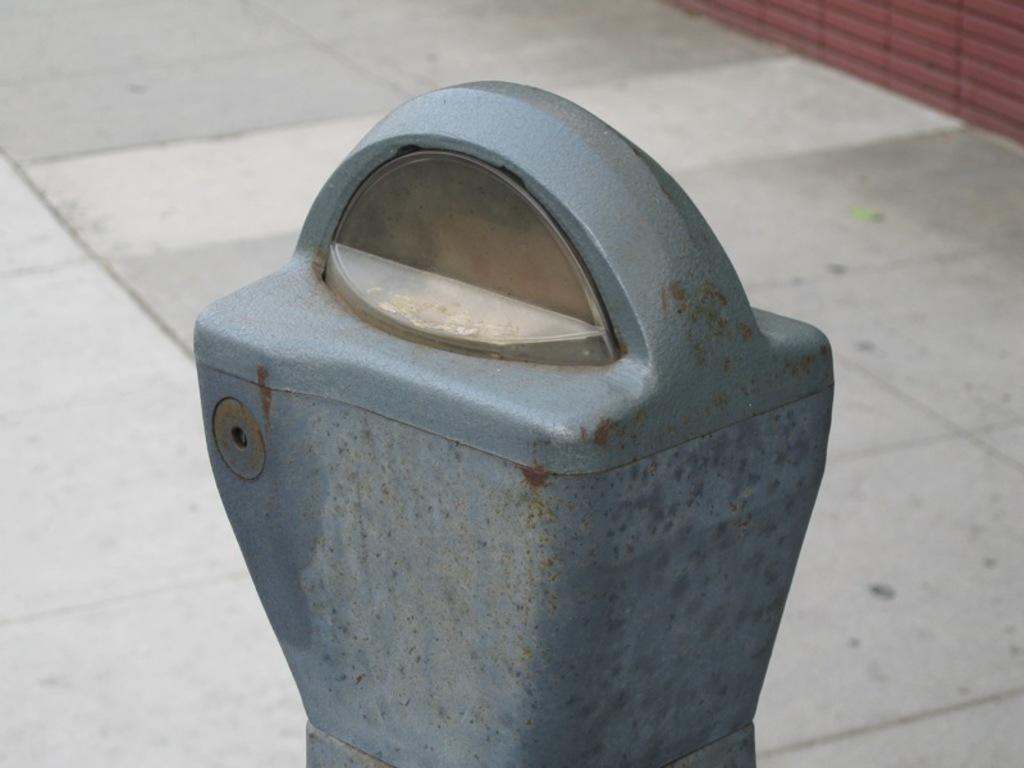How would you summarize this image in a sentence or two? In the image we can see there is a pole on the footpath. 